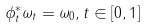<formula> <loc_0><loc_0><loc_500><loc_500>\phi _ { t } ^ { * } \omega _ { t } = \omega _ { 0 } , t \in [ 0 , 1 ]</formula> 